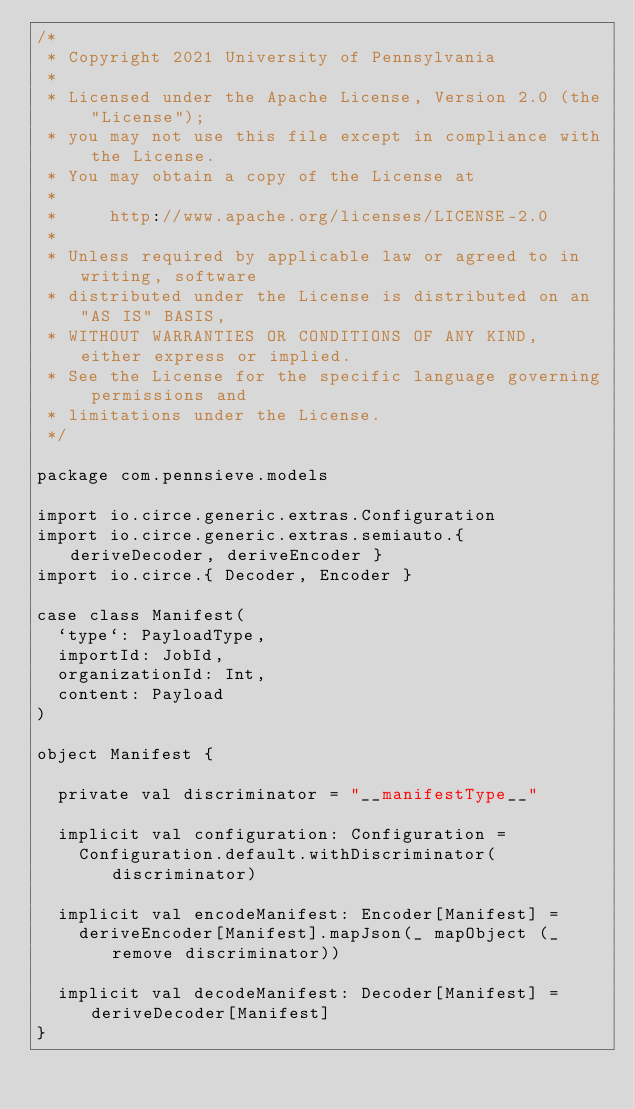<code> <loc_0><loc_0><loc_500><loc_500><_Scala_>/*
 * Copyright 2021 University of Pennsylvania
 *
 * Licensed under the Apache License, Version 2.0 (the "License");
 * you may not use this file except in compliance with the License.
 * You may obtain a copy of the License at
 *
 *     http://www.apache.org/licenses/LICENSE-2.0
 *
 * Unless required by applicable law or agreed to in writing, software
 * distributed under the License is distributed on an "AS IS" BASIS,
 * WITHOUT WARRANTIES OR CONDITIONS OF ANY KIND, either express or implied.
 * See the License for the specific language governing permissions and
 * limitations under the License.
 */

package com.pennsieve.models

import io.circe.generic.extras.Configuration
import io.circe.generic.extras.semiauto.{ deriveDecoder, deriveEncoder }
import io.circe.{ Decoder, Encoder }

case class Manifest(
  `type`: PayloadType,
  importId: JobId,
  organizationId: Int,
  content: Payload
)

object Manifest {

  private val discriminator = "__manifestType__"

  implicit val configuration: Configuration =
    Configuration.default.withDiscriminator(discriminator)

  implicit val encodeManifest: Encoder[Manifest] =
    deriveEncoder[Manifest].mapJson(_ mapObject (_ remove discriminator))

  implicit val decodeManifest: Decoder[Manifest] = deriveDecoder[Manifest]
}
</code> 